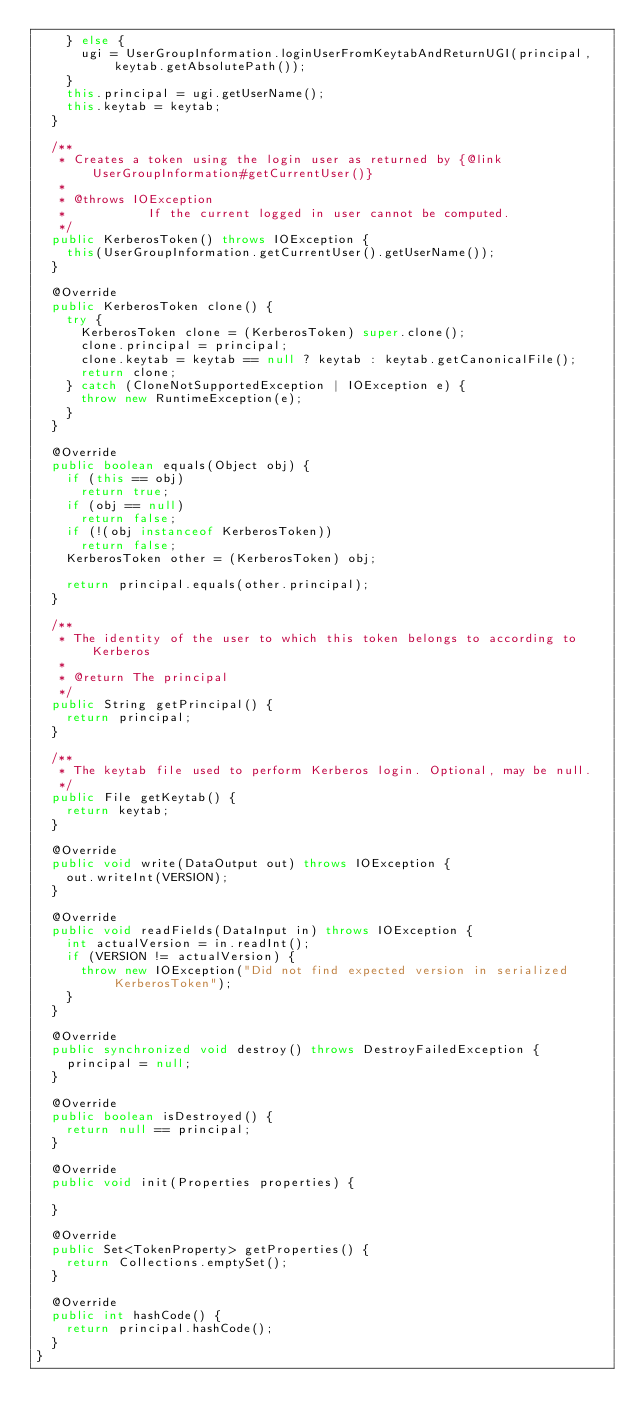Convert code to text. <code><loc_0><loc_0><loc_500><loc_500><_Java_>    } else {
      ugi = UserGroupInformation.loginUserFromKeytabAndReturnUGI(principal, keytab.getAbsolutePath());
    }
    this.principal = ugi.getUserName();
    this.keytab = keytab;
  }

  /**
   * Creates a token using the login user as returned by {@link UserGroupInformation#getCurrentUser()}
   *
   * @throws IOException
   *           If the current logged in user cannot be computed.
   */
  public KerberosToken() throws IOException {
    this(UserGroupInformation.getCurrentUser().getUserName());
  }

  @Override
  public KerberosToken clone() {
    try {
      KerberosToken clone = (KerberosToken) super.clone();
      clone.principal = principal;
      clone.keytab = keytab == null ? keytab : keytab.getCanonicalFile();
      return clone;
    } catch (CloneNotSupportedException | IOException e) {
      throw new RuntimeException(e);
    }
  }

  @Override
  public boolean equals(Object obj) {
    if (this == obj)
      return true;
    if (obj == null)
      return false;
    if (!(obj instanceof KerberosToken))
      return false;
    KerberosToken other = (KerberosToken) obj;

    return principal.equals(other.principal);
  }

  /**
   * The identity of the user to which this token belongs to according to Kerberos
   *
   * @return The principal
   */
  public String getPrincipal() {
    return principal;
  }

  /**
   * The keytab file used to perform Kerberos login. Optional, may be null.
   */
  public File getKeytab() {
    return keytab;
  }

  @Override
  public void write(DataOutput out) throws IOException {
    out.writeInt(VERSION);
  }

  @Override
  public void readFields(DataInput in) throws IOException {
    int actualVersion = in.readInt();
    if (VERSION != actualVersion) {
      throw new IOException("Did not find expected version in serialized KerberosToken");
    }
  }

  @Override
  public synchronized void destroy() throws DestroyFailedException {
    principal = null;
  }

  @Override
  public boolean isDestroyed() {
    return null == principal;
  }

  @Override
  public void init(Properties properties) {

  }

  @Override
  public Set<TokenProperty> getProperties() {
    return Collections.emptySet();
  }

  @Override
  public int hashCode() {
    return principal.hashCode();
  }
}
</code> 